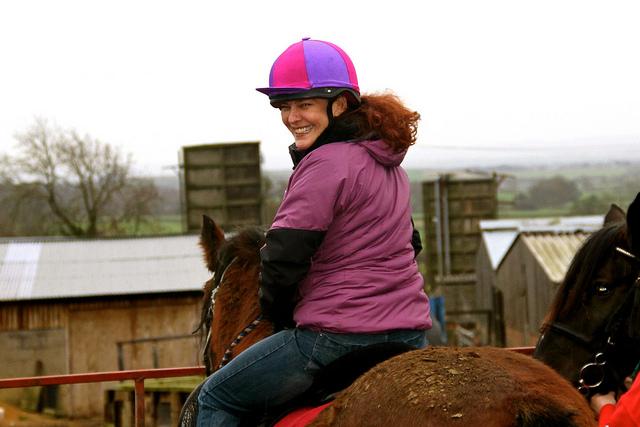What color is her helmet?
Quick response, please. Pink and purple. What is the person riding on?
Keep it brief. Horse. Is the lady happy?
Be succinct. Yes. What Animal is the woman riding in this scene?
Give a very brief answer. Horse. 